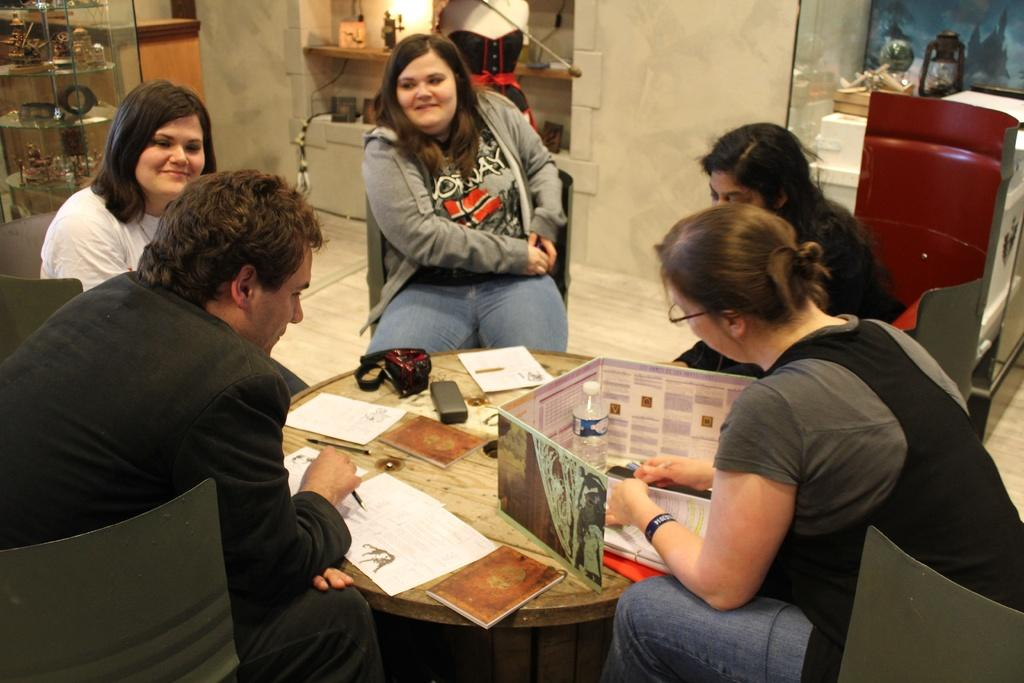What is happening in the image involving a group of people? There is a group of people in the image, and they are seated on chairs. What objects are present on the table in the image? There are papers and a bottle on the table in the image. Is there a pan being used on the stage in the image? There is no pan or stage present in the image. 